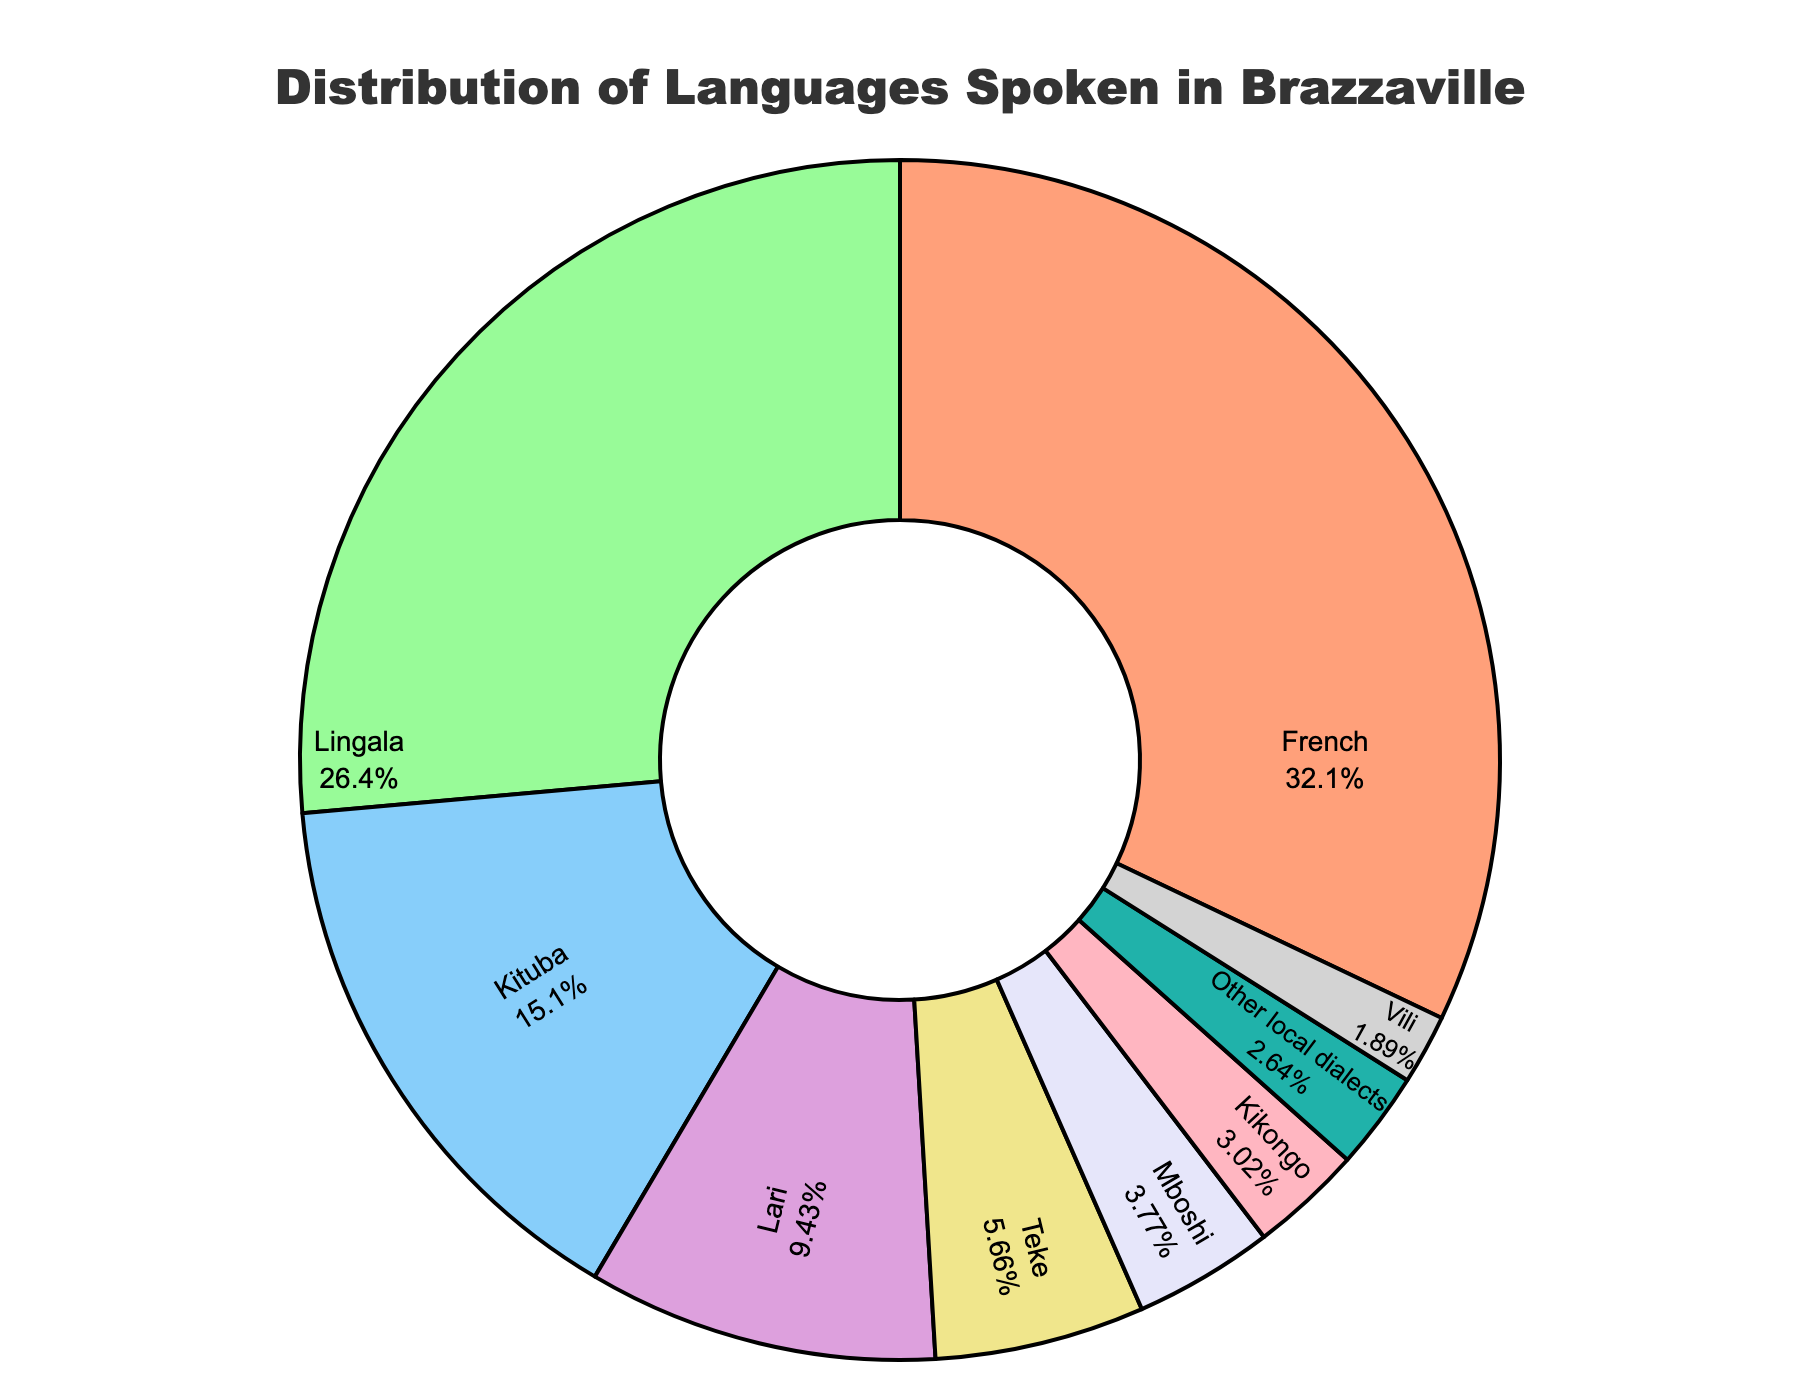Which language has the highest percentage of speakers in Brazzaville? The pie chart clearly shows sections with different percentages. The largest section corresponds to French with 85%.
Answer: French Which languages have a percentage of speakers less than 10%? The pie chart shows sections with varying percentages. By identifying those less than 10%, we find Mboshi (10%, very close but still below), Kikongo (8%), Vili (5%), and Other local dialects (7%).
Answer: Kikongo, Vili, Other local dialects What is the combined percentage of Lingala and Kituba speakers? By looking at the pie chart, we find the percentages for Lingala (70%) and Kituba (40%). Adding these together gives 70% + 40% = 110%.
Answer: 110% Which two languages have the smallest percentage difference in speakers? Examining the pie chart, we compare the adjacent sections: Lari (25%) and Teke (15%) have a difference of 10%; Teke (15%) and Mboshi (10%) have a difference of 5%. This is the smallest.
Answer: Teke and Mboshi What is the percentage difference between the most and least spoken languages? From the pie chart, the most spoken language is French at 85% and the least spoken language is Vili at 5%. The difference is 85% - 5% = 80%.
Answer: 80% Which language section in the pie chart uses red color, and what is its percentage? Looking at the visual aspects of the pie chart and corresponding colors, we see that the red section corresponds to French, which has 85%.
Answer: French, 85% Are there more Lingala speakers or speakers of all languages with percentages below 10%? Lingala’s percentage is 70%. Summing the languages below 10%: Mboshi (10%), Kikongo (8%), Vili (5%), and Other local dialects (7%) gives 10% + 8% + 5% + 7% = 30%. 70% is greater than 30%.
Answer: Lingala speakers How many languages have at least 20% of the population speaking them? From the pie chart, languages with at least 20% are French (85%), Lingala (70%), Kituba (40%), and Lari (25%). This gives us four languages.
Answer: 4 languages If you combine the percentages of French and Lingala speakers, what fraction of the total number do they represent? Adding French (85%) and Lingala (70%) gives 155%. Since the total is over 100%, it means French and Lingala combined exceed the total population by 55%, or they represent 155/100 = 1.55, which is 1 and 55% fractionally.
Answer: 1 and 55% 